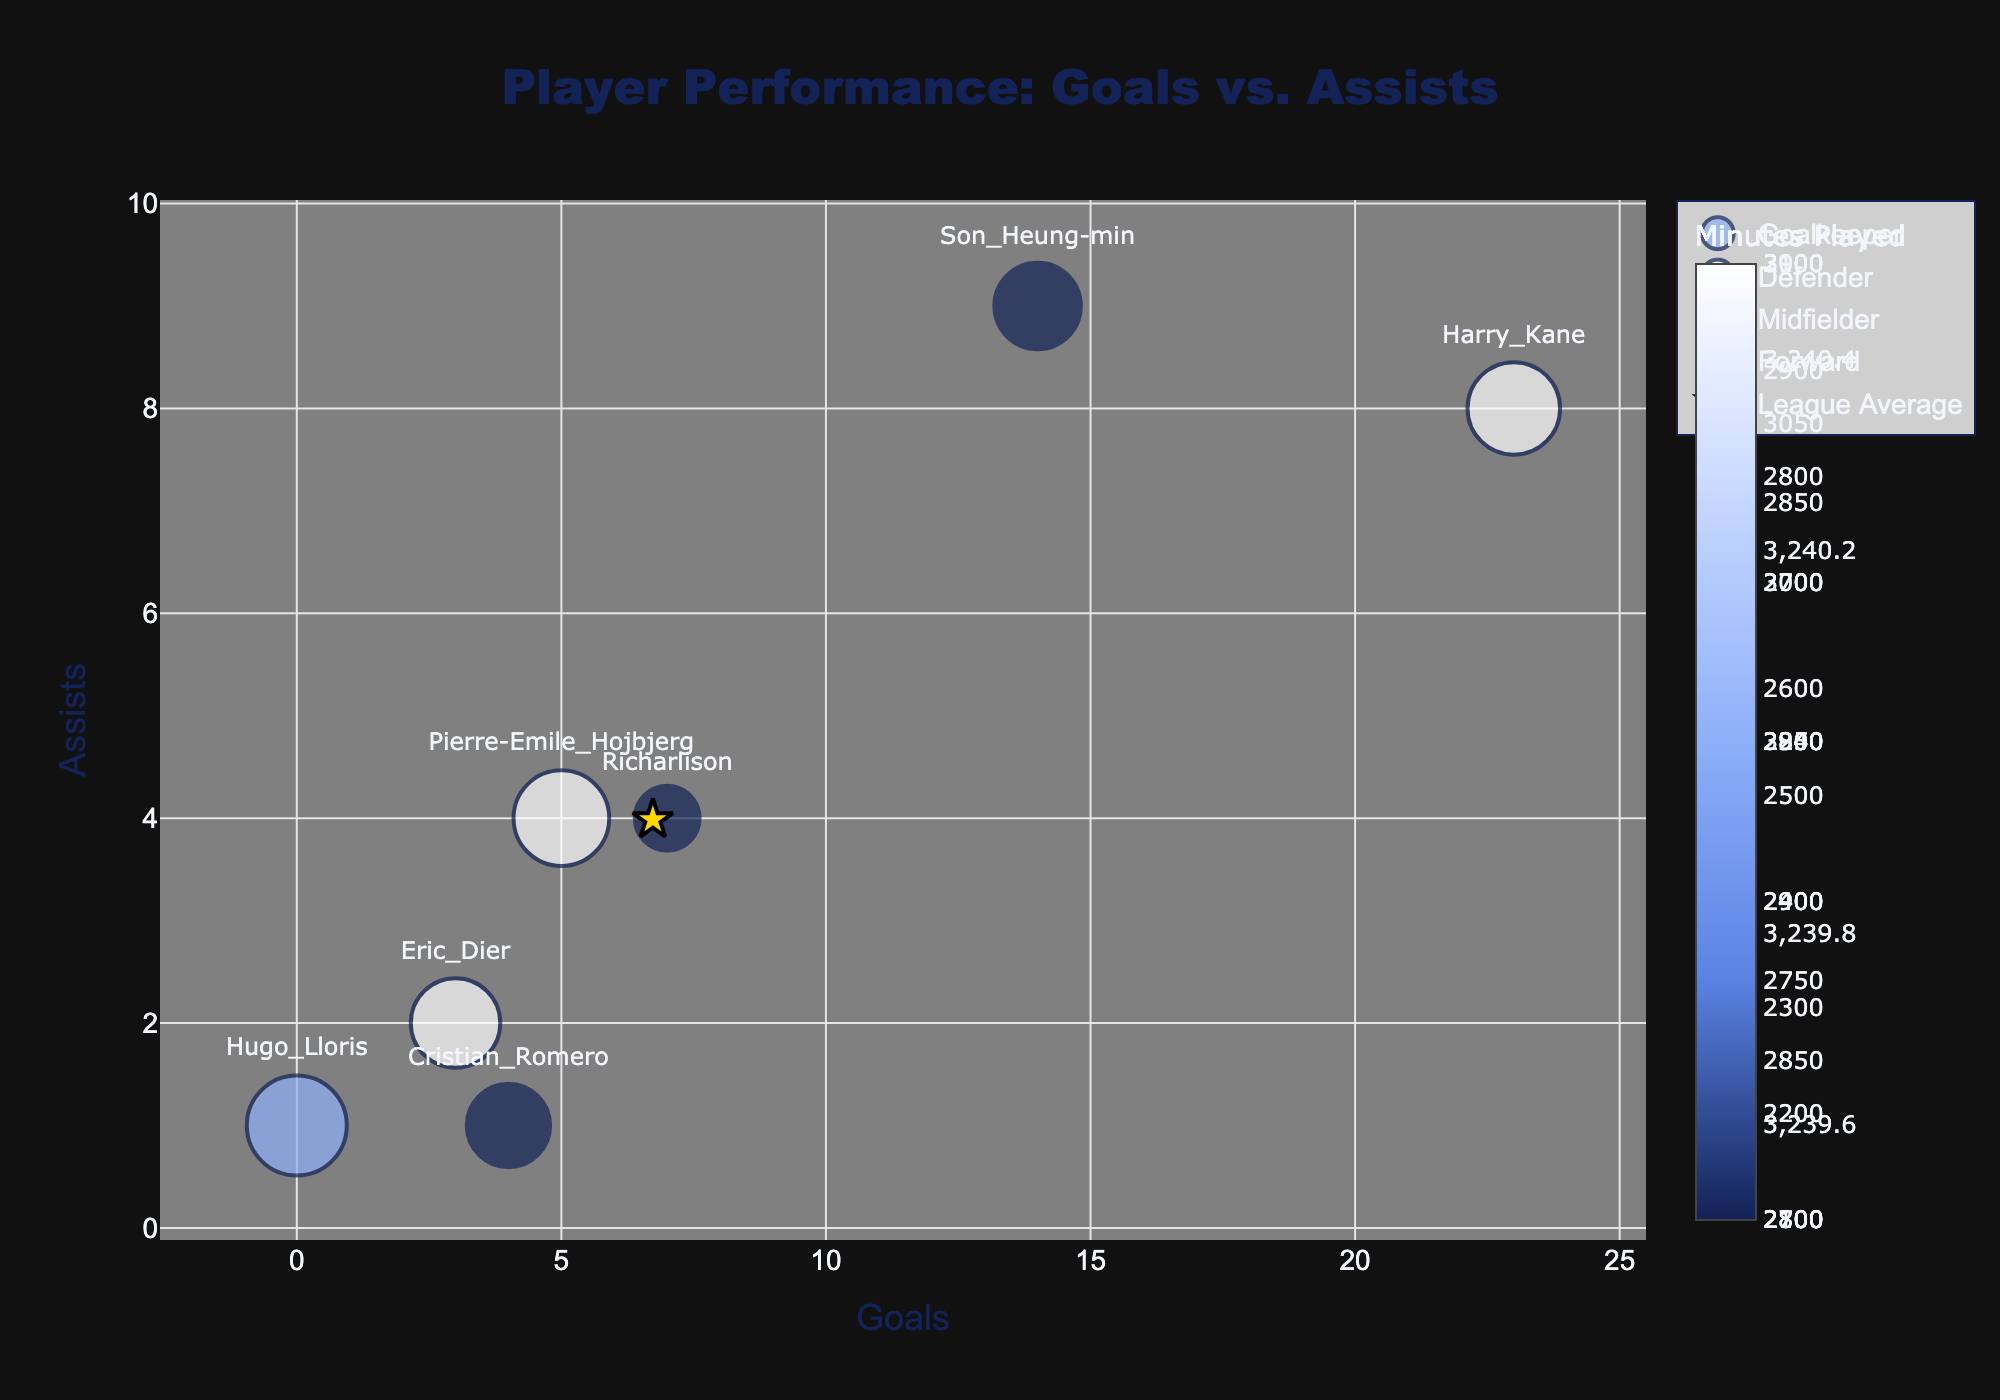What is the title of the figure? The title is displayed at the top center of the figure and reads "Player Performance: Goals vs. Assists".
Answer: Player Performance: Goals vs. Assists Which player has the largest bubble size and what does it represent? Hugo Lloris has the largest bubble size, representing his 3240 Minutes Played, which is the highest among the players.
Answer: Hugo Lloris What is the average number of goals and assists for league players shown by the star marker? The star marker indicates the league average, with average goals of around 6.1 and assists of about 3.9.
Answer: Goals: 6.1, Assists: 3.9 Which Tottenham Hotspur player scored the highest number of goals? Harry Kane scored the highest number of goals, which is 23. This is the furthest point to the right on the x-axis.
Answer: Harry Kane How do Harry Kane's assists compare to the league average assists? Harry Kane has 8 assists while the league average is approximately 3.9 assists, meaning he has a higher number of assists compared to the league average.
Answer: Higher What is the combined total of goals scored by the midfielders? Adding Son Heung-min's and Pierre-Emile Hojbjerg's goals: 14 + 5 = 19 goals.
Answer: 19 goals Which position has the player with the fewest minutes played? The player with the fewest minutes played is Richarlison, represented by a smaller bubble size with 2100 minutes, and he plays in the Forward position.
Answer: Forward Compare the goals for the defenders to the league average goals for defenders. Eric Dier and Cristian Romero have combined goals of 3 + 4 = 7, while the average for defenders is 2.5. This shows Tottenham defenders have collectively scored more goals than the league average for defenders.
Answer: More For Pierre-Emile Hojbjerg, are his assists above or below the league average for midfielders? Pierre-Emile Hojbjerg has 4 assists, which is below the league average of 5 assists for midfielders.
Answer: Below Which player is closest to the league average in both goals and assists? Pierre-Emile Hojbjerg, with 5 goals and 4 assists, compared to the league average of 6 goals and 5 assists, is the closest to these averages.
Answer: Pierre-Emile Hojbjerg 